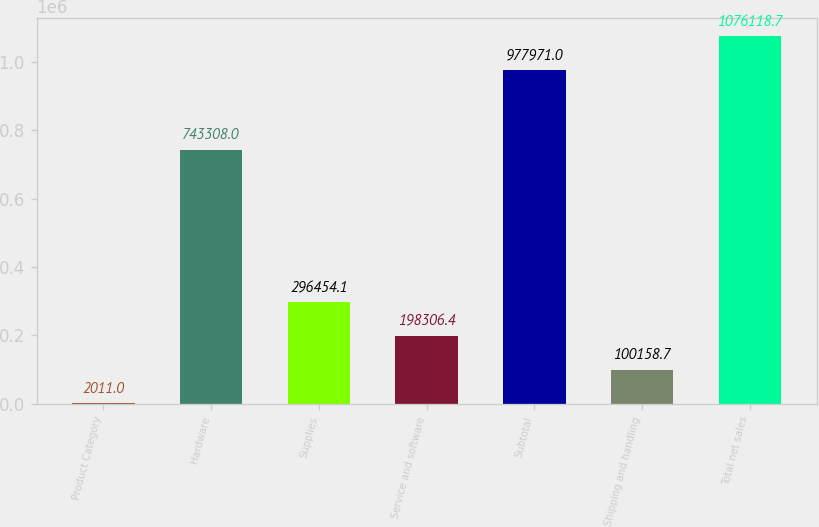Convert chart to OTSL. <chart><loc_0><loc_0><loc_500><loc_500><bar_chart><fcel>Product Category<fcel>Hardware<fcel>Supplies<fcel>Service and software<fcel>Subtotal<fcel>Shipping and handling<fcel>Total net sales<nl><fcel>2011<fcel>743308<fcel>296454<fcel>198306<fcel>977971<fcel>100159<fcel>1.07612e+06<nl></chart> 